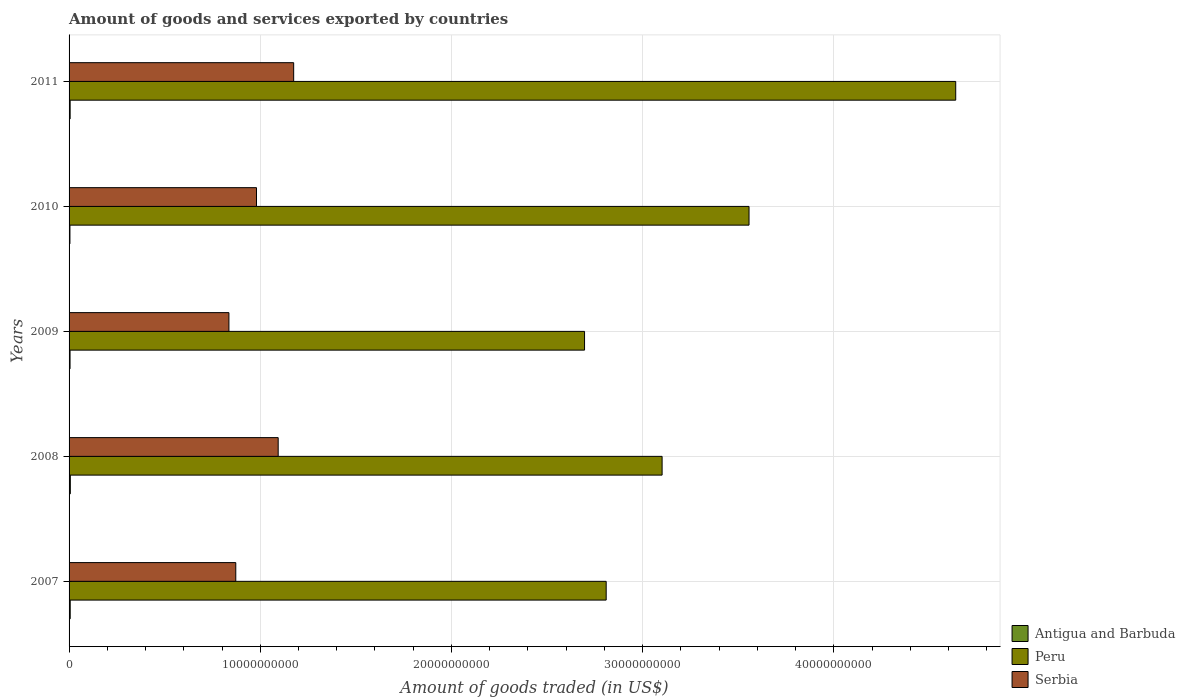How many groups of bars are there?
Provide a short and direct response. 5. Are the number of bars per tick equal to the number of legend labels?
Keep it short and to the point. Yes. How many bars are there on the 4th tick from the top?
Your answer should be compact. 3. What is the total amount of goods and services exported in Peru in 2008?
Ensure brevity in your answer.  3.10e+1. Across all years, what is the maximum total amount of goods and services exported in Serbia?
Provide a succinct answer. 1.17e+1. Across all years, what is the minimum total amount of goods and services exported in Antigua and Barbuda?
Provide a succinct answer. 4.57e+07. In which year was the total amount of goods and services exported in Antigua and Barbuda maximum?
Offer a very short reply. 2008. What is the total total amount of goods and services exported in Serbia in the graph?
Provide a short and direct response. 4.96e+1. What is the difference between the total amount of goods and services exported in Serbia in 2007 and that in 2009?
Offer a very short reply. 3.58e+08. What is the difference between the total amount of goods and services exported in Antigua and Barbuda in 2008 and the total amount of goods and services exported in Serbia in 2007?
Your answer should be compact. -8.65e+09. What is the average total amount of goods and services exported in Peru per year?
Give a very brief answer. 3.36e+1. In the year 2010, what is the difference between the total amount of goods and services exported in Antigua and Barbuda and total amount of goods and services exported in Peru?
Provide a succinct answer. -3.55e+1. What is the ratio of the total amount of goods and services exported in Serbia in 2010 to that in 2011?
Your answer should be very brief. 0.83. Is the total amount of goods and services exported in Peru in 2008 less than that in 2010?
Ensure brevity in your answer.  Yes. Is the difference between the total amount of goods and services exported in Antigua and Barbuda in 2009 and 2011 greater than the difference between the total amount of goods and services exported in Peru in 2009 and 2011?
Your answer should be compact. Yes. What is the difference between the highest and the second highest total amount of goods and services exported in Serbia?
Provide a short and direct response. 8.10e+08. What is the difference between the highest and the lowest total amount of goods and services exported in Peru?
Offer a terse response. 1.94e+1. In how many years, is the total amount of goods and services exported in Serbia greater than the average total amount of goods and services exported in Serbia taken over all years?
Offer a terse response. 2. Is the sum of the total amount of goods and services exported in Peru in 2007 and 2010 greater than the maximum total amount of goods and services exported in Antigua and Barbuda across all years?
Your answer should be compact. Yes. What does the 1st bar from the top in 2007 represents?
Offer a very short reply. Serbia. What does the 3rd bar from the bottom in 2011 represents?
Make the answer very short. Serbia. How many bars are there?
Make the answer very short. 15. How many years are there in the graph?
Provide a short and direct response. 5. What is the difference between two consecutive major ticks on the X-axis?
Provide a short and direct response. 1.00e+1. Does the graph contain any zero values?
Provide a short and direct response. No. Does the graph contain grids?
Offer a very short reply. Yes. How are the legend labels stacked?
Offer a very short reply. Vertical. What is the title of the graph?
Provide a succinct answer. Amount of goods and services exported by countries. What is the label or title of the X-axis?
Ensure brevity in your answer.  Amount of goods traded (in US$). What is the label or title of the Y-axis?
Make the answer very short. Years. What is the Amount of goods traded (in US$) in Antigua and Barbuda in 2007?
Offer a terse response. 5.93e+07. What is the Amount of goods traded (in US$) of Peru in 2007?
Offer a very short reply. 2.81e+1. What is the Amount of goods traded (in US$) of Serbia in 2007?
Provide a short and direct response. 8.72e+09. What is the Amount of goods traded (in US$) of Antigua and Barbuda in 2008?
Ensure brevity in your answer.  6.54e+07. What is the Amount of goods traded (in US$) of Peru in 2008?
Offer a very short reply. 3.10e+1. What is the Amount of goods traded (in US$) of Serbia in 2008?
Give a very brief answer. 1.09e+1. What is the Amount of goods traded (in US$) in Antigua and Barbuda in 2009?
Offer a terse response. 5.07e+07. What is the Amount of goods traded (in US$) in Peru in 2009?
Provide a succinct answer. 2.70e+1. What is the Amount of goods traded (in US$) of Serbia in 2009?
Offer a very short reply. 8.36e+09. What is the Amount of goods traded (in US$) in Antigua and Barbuda in 2010?
Give a very brief answer. 4.57e+07. What is the Amount of goods traded (in US$) of Peru in 2010?
Offer a terse response. 3.56e+1. What is the Amount of goods traded (in US$) in Serbia in 2010?
Your answer should be compact. 9.80e+09. What is the Amount of goods traded (in US$) in Antigua and Barbuda in 2011?
Make the answer very short. 5.62e+07. What is the Amount of goods traded (in US$) in Peru in 2011?
Offer a very short reply. 4.64e+1. What is the Amount of goods traded (in US$) of Serbia in 2011?
Offer a terse response. 1.17e+1. Across all years, what is the maximum Amount of goods traded (in US$) in Antigua and Barbuda?
Your response must be concise. 6.54e+07. Across all years, what is the maximum Amount of goods traded (in US$) of Peru?
Keep it short and to the point. 4.64e+1. Across all years, what is the maximum Amount of goods traded (in US$) of Serbia?
Ensure brevity in your answer.  1.17e+1. Across all years, what is the minimum Amount of goods traded (in US$) of Antigua and Barbuda?
Offer a terse response. 4.57e+07. Across all years, what is the minimum Amount of goods traded (in US$) in Peru?
Provide a short and direct response. 2.70e+1. Across all years, what is the minimum Amount of goods traded (in US$) of Serbia?
Offer a very short reply. 8.36e+09. What is the total Amount of goods traded (in US$) in Antigua and Barbuda in the graph?
Offer a very short reply. 2.77e+08. What is the total Amount of goods traded (in US$) in Peru in the graph?
Keep it short and to the point. 1.68e+11. What is the total Amount of goods traded (in US$) of Serbia in the graph?
Ensure brevity in your answer.  4.96e+1. What is the difference between the Amount of goods traded (in US$) in Antigua and Barbuda in 2007 and that in 2008?
Your response must be concise. -6.10e+06. What is the difference between the Amount of goods traded (in US$) of Peru in 2007 and that in 2008?
Your answer should be compact. -2.92e+09. What is the difference between the Amount of goods traded (in US$) in Serbia in 2007 and that in 2008?
Your response must be concise. -2.22e+09. What is the difference between the Amount of goods traded (in US$) in Antigua and Barbuda in 2007 and that in 2009?
Provide a succinct answer. 8.54e+06. What is the difference between the Amount of goods traded (in US$) in Peru in 2007 and that in 2009?
Provide a short and direct response. 1.13e+09. What is the difference between the Amount of goods traded (in US$) in Serbia in 2007 and that in 2009?
Offer a very short reply. 3.58e+08. What is the difference between the Amount of goods traded (in US$) in Antigua and Barbuda in 2007 and that in 2010?
Your answer should be compact. 1.36e+07. What is the difference between the Amount of goods traded (in US$) of Peru in 2007 and that in 2010?
Make the answer very short. -7.47e+09. What is the difference between the Amount of goods traded (in US$) in Serbia in 2007 and that in 2010?
Ensure brevity in your answer.  -1.08e+09. What is the difference between the Amount of goods traded (in US$) in Antigua and Barbuda in 2007 and that in 2011?
Ensure brevity in your answer.  3.13e+06. What is the difference between the Amount of goods traded (in US$) in Peru in 2007 and that in 2011?
Your answer should be compact. -1.83e+1. What is the difference between the Amount of goods traded (in US$) of Serbia in 2007 and that in 2011?
Ensure brevity in your answer.  -3.03e+09. What is the difference between the Amount of goods traded (in US$) of Antigua and Barbuda in 2008 and that in 2009?
Provide a succinct answer. 1.46e+07. What is the difference between the Amount of goods traded (in US$) of Peru in 2008 and that in 2009?
Provide a short and direct response. 4.06e+09. What is the difference between the Amount of goods traded (in US$) of Serbia in 2008 and that in 2009?
Give a very brief answer. 2.58e+09. What is the difference between the Amount of goods traded (in US$) of Antigua and Barbuda in 2008 and that in 2010?
Offer a very short reply. 1.97e+07. What is the difference between the Amount of goods traded (in US$) of Peru in 2008 and that in 2010?
Provide a short and direct response. -4.55e+09. What is the difference between the Amount of goods traded (in US$) in Serbia in 2008 and that in 2010?
Keep it short and to the point. 1.13e+09. What is the difference between the Amount of goods traded (in US$) of Antigua and Barbuda in 2008 and that in 2011?
Your answer should be very brief. 9.23e+06. What is the difference between the Amount of goods traded (in US$) of Peru in 2008 and that in 2011?
Ensure brevity in your answer.  -1.54e+1. What is the difference between the Amount of goods traded (in US$) of Serbia in 2008 and that in 2011?
Your answer should be compact. -8.10e+08. What is the difference between the Amount of goods traded (in US$) of Antigua and Barbuda in 2009 and that in 2010?
Your answer should be compact. 5.03e+06. What is the difference between the Amount of goods traded (in US$) of Peru in 2009 and that in 2010?
Your response must be concise. -8.60e+09. What is the difference between the Amount of goods traded (in US$) in Serbia in 2009 and that in 2010?
Your answer should be compact. -1.44e+09. What is the difference between the Amount of goods traded (in US$) in Antigua and Barbuda in 2009 and that in 2011?
Make the answer very short. -5.41e+06. What is the difference between the Amount of goods traded (in US$) in Peru in 2009 and that in 2011?
Make the answer very short. -1.94e+1. What is the difference between the Amount of goods traded (in US$) of Serbia in 2009 and that in 2011?
Offer a terse response. -3.39e+09. What is the difference between the Amount of goods traded (in US$) of Antigua and Barbuda in 2010 and that in 2011?
Make the answer very short. -1.04e+07. What is the difference between the Amount of goods traded (in US$) in Peru in 2010 and that in 2011?
Keep it short and to the point. -1.08e+1. What is the difference between the Amount of goods traded (in US$) in Serbia in 2010 and that in 2011?
Keep it short and to the point. -1.94e+09. What is the difference between the Amount of goods traded (in US$) of Antigua and Barbuda in 2007 and the Amount of goods traded (in US$) of Peru in 2008?
Offer a very short reply. -3.10e+1. What is the difference between the Amount of goods traded (in US$) in Antigua and Barbuda in 2007 and the Amount of goods traded (in US$) in Serbia in 2008?
Your answer should be compact. -1.09e+1. What is the difference between the Amount of goods traded (in US$) of Peru in 2007 and the Amount of goods traded (in US$) of Serbia in 2008?
Ensure brevity in your answer.  1.72e+1. What is the difference between the Amount of goods traded (in US$) in Antigua and Barbuda in 2007 and the Amount of goods traded (in US$) in Peru in 2009?
Offer a very short reply. -2.69e+1. What is the difference between the Amount of goods traded (in US$) in Antigua and Barbuda in 2007 and the Amount of goods traded (in US$) in Serbia in 2009?
Offer a terse response. -8.30e+09. What is the difference between the Amount of goods traded (in US$) in Peru in 2007 and the Amount of goods traded (in US$) in Serbia in 2009?
Your answer should be very brief. 1.97e+1. What is the difference between the Amount of goods traded (in US$) in Antigua and Barbuda in 2007 and the Amount of goods traded (in US$) in Peru in 2010?
Provide a short and direct response. -3.55e+1. What is the difference between the Amount of goods traded (in US$) in Antigua and Barbuda in 2007 and the Amount of goods traded (in US$) in Serbia in 2010?
Your answer should be compact. -9.74e+09. What is the difference between the Amount of goods traded (in US$) of Peru in 2007 and the Amount of goods traded (in US$) of Serbia in 2010?
Offer a very short reply. 1.83e+1. What is the difference between the Amount of goods traded (in US$) of Antigua and Barbuda in 2007 and the Amount of goods traded (in US$) of Peru in 2011?
Provide a short and direct response. -4.63e+1. What is the difference between the Amount of goods traded (in US$) in Antigua and Barbuda in 2007 and the Amount of goods traded (in US$) in Serbia in 2011?
Provide a succinct answer. -1.17e+1. What is the difference between the Amount of goods traded (in US$) of Peru in 2007 and the Amount of goods traded (in US$) of Serbia in 2011?
Provide a short and direct response. 1.63e+1. What is the difference between the Amount of goods traded (in US$) of Antigua and Barbuda in 2008 and the Amount of goods traded (in US$) of Peru in 2009?
Ensure brevity in your answer.  -2.69e+1. What is the difference between the Amount of goods traded (in US$) of Antigua and Barbuda in 2008 and the Amount of goods traded (in US$) of Serbia in 2009?
Give a very brief answer. -8.30e+09. What is the difference between the Amount of goods traded (in US$) in Peru in 2008 and the Amount of goods traded (in US$) in Serbia in 2009?
Your response must be concise. 2.27e+1. What is the difference between the Amount of goods traded (in US$) in Antigua and Barbuda in 2008 and the Amount of goods traded (in US$) in Peru in 2010?
Keep it short and to the point. -3.55e+1. What is the difference between the Amount of goods traded (in US$) in Antigua and Barbuda in 2008 and the Amount of goods traded (in US$) in Serbia in 2010?
Ensure brevity in your answer.  -9.74e+09. What is the difference between the Amount of goods traded (in US$) in Peru in 2008 and the Amount of goods traded (in US$) in Serbia in 2010?
Your answer should be very brief. 2.12e+1. What is the difference between the Amount of goods traded (in US$) in Antigua and Barbuda in 2008 and the Amount of goods traded (in US$) in Peru in 2011?
Offer a very short reply. -4.63e+1. What is the difference between the Amount of goods traded (in US$) of Antigua and Barbuda in 2008 and the Amount of goods traded (in US$) of Serbia in 2011?
Offer a terse response. -1.17e+1. What is the difference between the Amount of goods traded (in US$) of Peru in 2008 and the Amount of goods traded (in US$) of Serbia in 2011?
Ensure brevity in your answer.  1.93e+1. What is the difference between the Amount of goods traded (in US$) of Antigua and Barbuda in 2009 and the Amount of goods traded (in US$) of Peru in 2010?
Your response must be concise. -3.55e+1. What is the difference between the Amount of goods traded (in US$) of Antigua and Barbuda in 2009 and the Amount of goods traded (in US$) of Serbia in 2010?
Give a very brief answer. -9.75e+09. What is the difference between the Amount of goods traded (in US$) of Peru in 2009 and the Amount of goods traded (in US$) of Serbia in 2010?
Your response must be concise. 1.72e+1. What is the difference between the Amount of goods traded (in US$) of Antigua and Barbuda in 2009 and the Amount of goods traded (in US$) of Peru in 2011?
Your response must be concise. -4.63e+1. What is the difference between the Amount of goods traded (in US$) of Antigua and Barbuda in 2009 and the Amount of goods traded (in US$) of Serbia in 2011?
Give a very brief answer. -1.17e+1. What is the difference between the Amount of goods traded (in US$) in Peru in 2009 and the Amount of goods traded (in US$) in Serbia in 2011?
Provide a succinct answer. 1.52e+1. What is the difference between the Amount of goods traded (in US$) in Antigua and Barbuda in 2010 and the Amount of goods traded (in US$) in Peru in 2011?
Make the answer very short. -4.63e+1. What is the difference between the Amount of goods traded (in US$) of Antigua and Barbuda in 2010 and the Amount of goods traded (in US$) of Serbia in 2011?
Make the answer very short. -1.17e+1. What is the difference between the Amount of goods traded (in US$) in Peru in 2010 and the Amount of goods traded (in US$) in Serbia in 2011?
Your answer should be very brief. 2.38e+1. What is the average Amount of goods traded (in US$) of Antigua and Barbuda per year?
Ensure brevity in your answer.  5.55e+07. What is the average Amount of goods traded (in US$) in Peru per year?
Ensure brevity in your answer.  3.36e+1. What is the average Amount of goods traded (in US$) in Serbia per year?
Make the answer very short. 9.91e+09. In the year 2007, what is the difference between the Amount of goods traded (in US$) in Antigua and Barbuda and Amount of goods traded (in US$) in Peru?
Give a very brief answer. -2.80e+1. In the year 2007, what is the difference between the Amount of goods traded (in US$) in Antigua and Barbuda and Amount of goods traded (in US$) in Serbia?
Offer a very short reply. -8.66e+09. In the year 2007, what is the difference between the Amount of goods traded (in US$) of Peru and Amount of goods traded (in US$) of Serbia?
Your answer should be very brief. 1.94e+1. In the year 2008, what is the difference between the Amount of goods traded (in US$) of Antigua and Barbuda and Amount of goods traded (in US$) of Peru?
Your response must be concise. -3.10e+1. In the year 2008, what is the difference between the Amount of goods traded (in US$) of Antigua and Barbuda and Amount of goods traded (in US$) of Serbia?
Your answer should be very brief. -1.09e+1. In the year 2008, what is the difference between the Amount of goods traded (in US$) of Peru and Amount of goods traded (in US$) of Serbia?
Offer a very short reply. 2.01e+1. In the year 2009, what is the difference between the Amount of goods traded (in US$) of Antigua and Barbuda and Amount of goods traded (in US$) of Peru?
Provide a succinct answer. -2.69e+1. In the year 2009, what is the difference between the Amount of goods traded (in US$) in Antigua and Barbuda and Amount of goods traded (in US$) in Serbia?
Provide a succinct answer. -8.31e+09. In the year 2009, what is the difference between the Amount of goods traded (in US$) of Peru and Amount of goods traded (in US$) of Serbia?
Offer a terse response. 1.86e+1. In the year 2010, what is the difference between the Amount of goods traded (in US$) in Antigua and Barbuda and Amount of goods traded (in US$) in Peru?
Ensure brevity in your answer.  -3.55e+1. In the year 2010, what is the difference between the Amount of goods traded (in US$) of Antigua and Barbuda and Amount of goods traded (in US$) of Serbia?
Provide a succinct answer. -9.76e+09. In the year 2010, what is the difference between the Amount of goods traded (in US$) of Peru and Amount of goods traded (in US$) of Serbia?
Your response must be concise. 2.58e+1. In the year 2011, what is the difference between the Amount of goods traded (in US$) in Antigua and Barbuda and Amount of goods traded (in US$) in Peru?
Offer a terse response. -4.63e+1. In the year 2011, what is the difference between the Amount of goods traded (in US$) in Antigua and Barbuda and Amount of goods traded (in US$) in Serbia?
Provide a short and direct response. -1.17e+1. In the year 2011, what is the difference between the Amount of goods traded (in US$) of Peru and Amount of goods traded (in US$) of Serbia?
Keep it short and to the point. 3.46e+1. What is the ratio of the Amount of goods traded (in US$) of Antigua and Barbuda in 2007 to that in 2008?
Offer a terse response. 0.91. What is the ratio of the Amount of goods traded (in US$) of Peru in 2007 to that in 2008?
Ensure brevity in your answer.  0.91. What is the ratio of the Amount of goods traded (in US$) of Serbia in 2007 to that in 2008?
Provide a succinct answer. 0.8. What is the ratio of the Amount of goods traded (in US$) in Antigua and Barbuda in 2007 to that in 2009?
Ensure brevity in your answer.  1.17. What is the ratio of the Amount of goods traded (in US$) of Peru in 2007 to that in 2009?
Your answer should be compact. 1.04. What is the ratio of the Amount of goods traded (in US$) of Serbia in 2007 to that in 2009?
Offer a very short reply. 1.04. What is the ratio of the Amount of goods traded (in US$) of Antigua and Barbuda in 2007 to that in 2010?
Your answer should be compact. 1.3. What is the ratio of the Amount of goods traded (in US$) in Peru in 2007 to that in 2010?
Provide a short and direct response. 0.79. What is the ratio of the Amount of goods traded (in US$) in Serbia in 2007 to that in 2010?
Provide a short and direct response. 0.89. What is the ratio of the Amount of goods traded (in US$) in Antigua and Barbuda in 2007 to that in 2011?
Make the answer very short. 1.06. What is the ratio of the Amount of goods traded (in US$) in Peru in 2007 to that in 2011?
Make the answer very short. 0.61. What is the ratio of the Amount of goods traded (in US$) in Serbia in 2007 to that in 2011?
Your answer should be very brief. 0.74. What is the ratio of the Amount of goods traded (in US$) of Antigua and Barbuda in 2008 to that in 2009?
Ensure brevity in your answer.  1.29. What is the ratio of the Amount of goods traded (in US$) in Peru in 2008 to that in 2009?
Keep it short and to the point. 1.15. What is the ratio of the Amount of goods traded (in US$) of Serbia in 2008 to that in 2009?
Your answer should be compact. 1.31. What is the ratio of the Amount of goods traded (in US$) in Antigua and Barbuda in 2008 to that in 2010?
Keep it short and to the point. 1.43. What is the ratio of the Amount of goods traded (in US$) in Peru in 2008 to that in 2010?
Offer a terse response. 0.87. What is the ratio of the Amount of goods traded (in US$) in Serbia in 2008 to that in 2010?
Your answer should be compact. 1.12. What is the ratio of the Amount of goods traded (in US$) of Antigua and Barbuda in 2008 to that in 2011?
Ensure brevity in your answer.  1.16. What is the ratio of the Amount of goods traded (in US$) of Peru in 2008 to that in 2011?
Provide a succinct answer. 0.67. What is the ratio of the Amount of goods traded (in US$) of Serbia in 2008 to that in 2011?
Offer a very short reply. 0.93. What is the ratio of the Amount of goods traded (in US$) of Antigua and Barbuda in 2009 to that in 2010?
Offer a very short reply. 1.11. What is the ratio of the Amount of goods traded (in US$) in Peru in 2009 to that in 2010?
Offer a very short reply. 0.76. What is the ratio of the Amount of goods traded (in US$) in Serbia in 2009 to that in 2010?
Your answer should be compact. 0.85. What is the ratio of the Amount of goods traded (in US$) in Antigua and Barbuda in 2009 to that in 2011?
Provide a short and direct response. 0.9. What is the ratio of the Amount of goods traded (in US$) of Peru in 2009 to that in 2011?
Make the answer very short. 0.58. What is the ratio of the Amount of goods traded (in US$) of Serbia in 2009 to that in 2011?
Offer a very short reply. 0.71. What is the ratio of the Amount of goods traded (in US$) of Antigua and Barbuda in 2010 to that in 2011?
Keep it short and to the point. 0.81. What is the ratio of the Amount of goods traded (in US$) of Peru in 2010 to that in 2011?
Your response must be concise. 0.77. What is the ratio of the Amount of goods traded (in US$) of Serbia in 2010 to that in 2011?
Keep it short and to the point. 0.83. What is the difference between the highest and the second highest Amount of goods traded (in US$) in Antigua and Barbuda?
Offer a very short reply. 6.10e+06. What is the difference between the highest and the second highest Amount of goods traded (in US$) of Peru?
Ensure brevity in your answer.  1.08e+1. What is the difference between the highest and the second highest Amount of goods traded (in US$) in Serbia?
Your answer should be compact. 8.10e+08. What is the difference between the highest and the lowest Amount of goods traded (in US$) in Antigua and Barbuda?
Your answer should be compact. 1.97e+07. What is the difference between the highest and the lowest Amount of goods traded (in US$) in Peru?
Your response must be concise. 1.94e+1. What is the difference between the highest and the lowest Amount of goods traded (in US$) in Serbia?
Your answer should be very brief. 3.39e+09. 